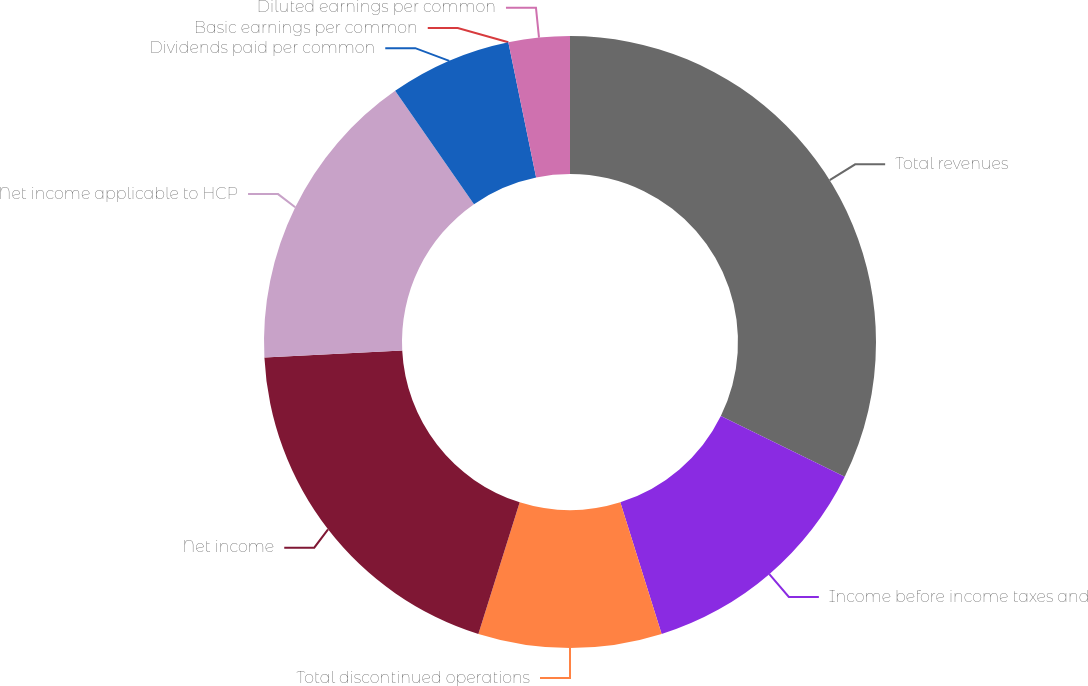Convert chart to OTSL. <chart><loc_0><loc_0><loc_500><loc_500><pie_chart><fcel>Total revenues<fcel>Income before income taxes and<fcel>Total discontinued operations<fcel>Net income<fcel>Net income applicable to HCP<fcel>Dividends paid per common<fcel>Basic earnings per common<fcel>Diluted earnings per common<nl><fcel>32.26%<fcel>12.9%<fcel>9.68%<fcel>19.35%<fcel>16.13%<fcel>6.45%<fcel>0.0%<fcel>3.23%<nl></chart> 